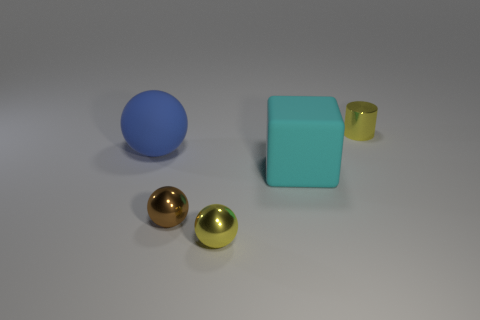Subtract all tiny balls. How many balls are left? 1 Subtract all blue balls. How many balls are left? 2 Subtract all spheres. How many objects are left? 2 Subtract 2 balls. How many balls are left? 1 Add 4 spheres. How many objects exist? 9 Subtract 0 gray spheres. How many objects are left? 5 Subtract all cyan balls. Subtract all brown blocks. How many balls are left? 3 Subtract all blue balls. How many blue cylinders are left? 0 Subtract all large gray cylinders. Subtract all large spheres. How many objects are left? 4 Add 2 spheres. How many spheres are left? 5 